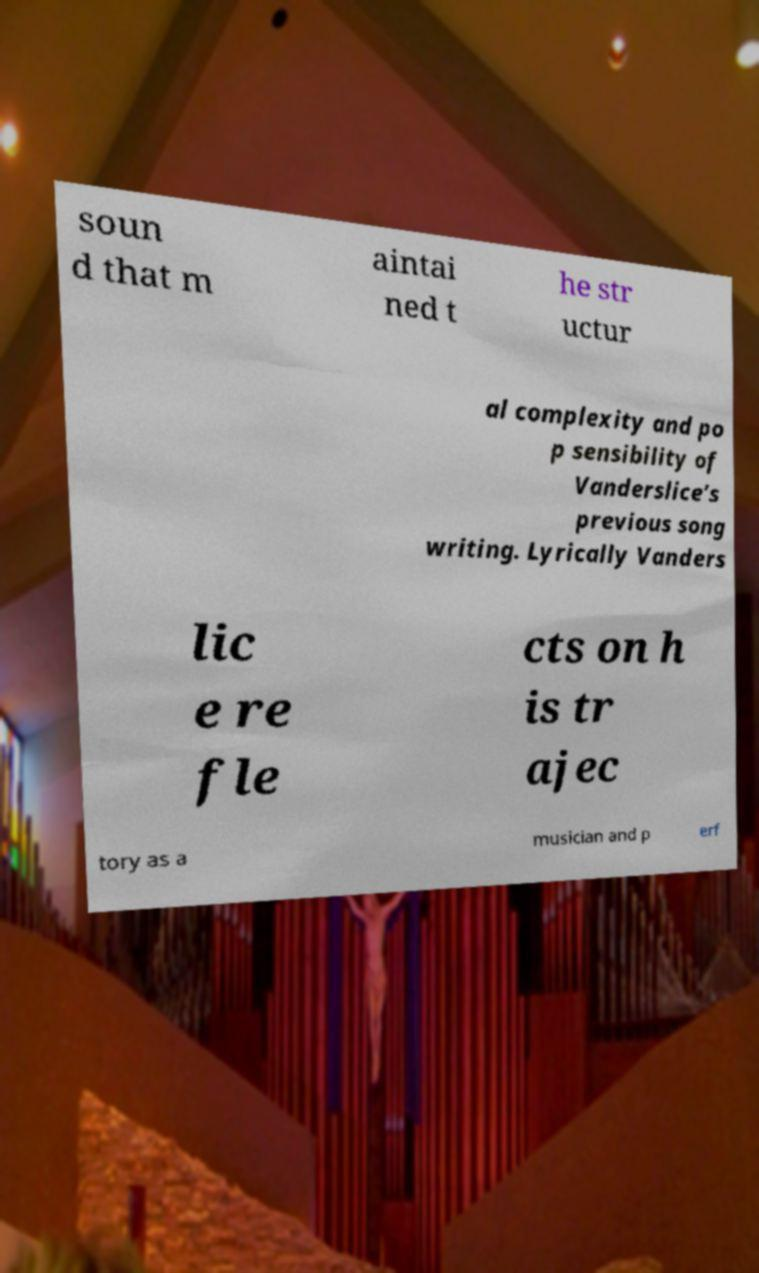Can you accurately transcribe the text from the provided image for me? soun d that m aintai ned t he str uctur al complexity and po p sensibility of Vanderslice’s previous song writing. Lyrically Vanders lic e re fle cts on h is tr ajec tory as a musician and p erf 